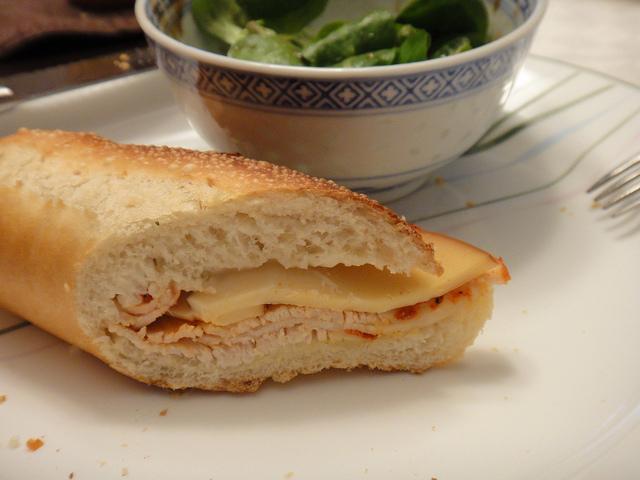How many bowls can you see?
Give a very brief answer. 1. How many people are in the picture?
Give a very brief answer. 0. 